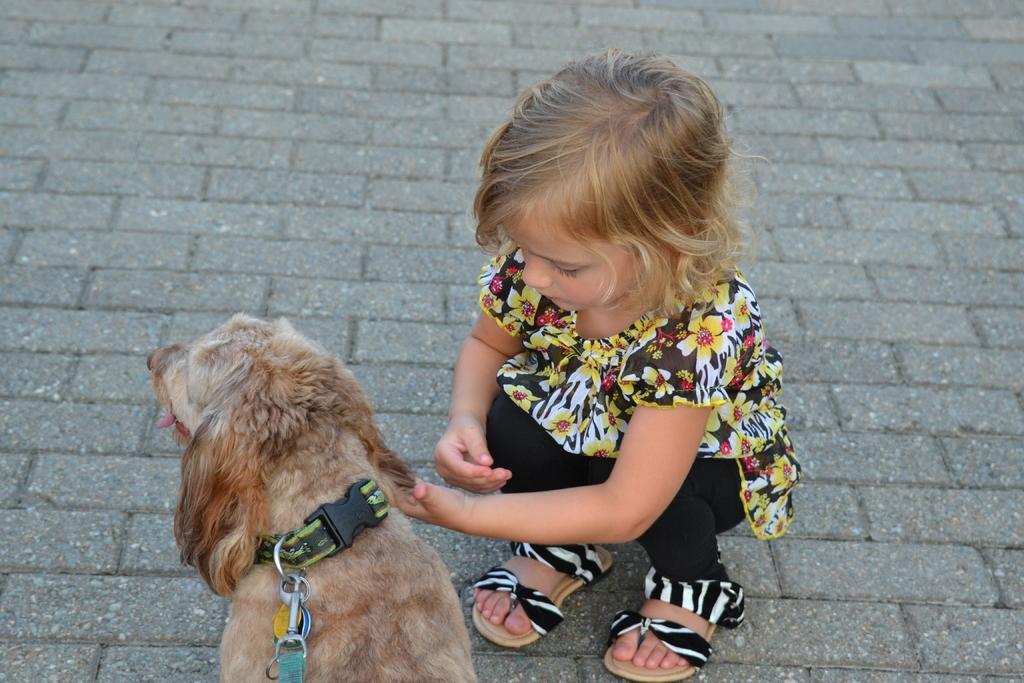Who is the main subject in the image? There is a girl in the image. What is the girl holding in the image? The girl is holding a dog. Where is the dog located in the image? The dog is on the floor. What can be seen in the background of the image? There is a floor made up of blocks in the background of the image. What type of jam is the girl spreading on the dog in the image? There is no jam present in the image, nor is the girl spreading anything on the dog. 